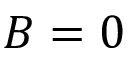<formula> <loc_0><loc_0><loc_500><loc_500>B = 0</formula> 